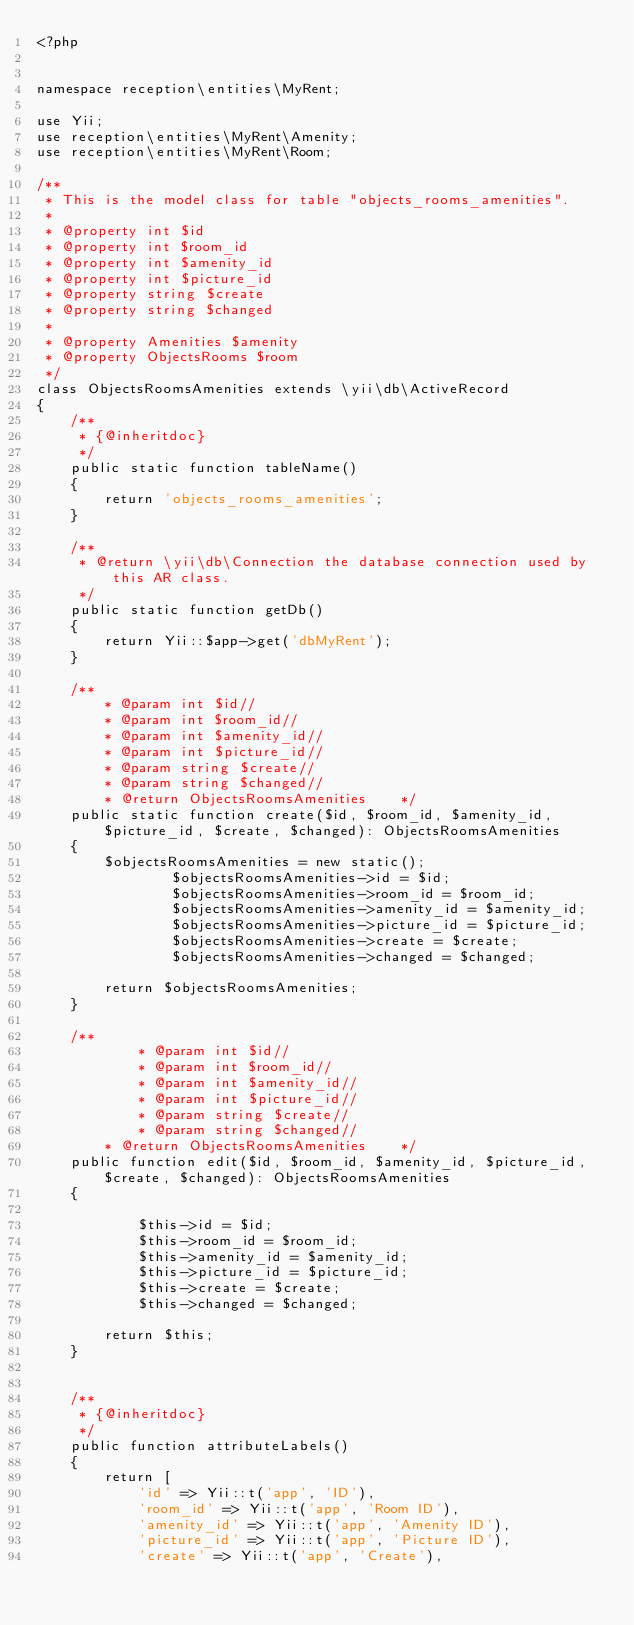Convert code to text. <code><loc_0><loc_0><loc_500><loc_500><_PHP_><?php


namespace reception\entities\MyRent;

use Yii;
use reception\entities\MyRent\Amenity;
use reception\entities\MyRent\Room;

/**
 * This is the model class for table "objects_rooms_amenities".
 *
 * @property int $id
 * @property int $room_id
 * @property int $amenity_id
 * @property int $picture_id
 * @property string $create
 * @property string $changed
 *
 * @property Amenities $amenity
 * @property ObjectsRooms $room
 */
class ObjectsRoomsAmenities extends \yii\db\ActiveRecord
{
    /**
     * {@inheritdoc}
     */
    public static function tableName()
    {
        return 'objects_rooms_amenities';
    }

    /**
     * @return \yii\db\Connection the database connection used by this AR class.
     */
    public static function getDb()
    {
        return Yii::$app->get('dbMyRent');
    }

    /**
        * @param int $id//
        * @param int $room_id//
        * @param int $amenity_id//
        * @param int $picture_id//
        * @param string $create//
        * @param string $changed//
        * @return ObjectsRoomsAmenities    */
    public static function create($id, $room_id, $amenity_id, $picture_id, $create, $changed): ObjectsRoomsAmenities
    {
        $objectsRoomsAmenities = new static();
                $objectsRoomsAmenities->id = $id;
                $objectsRoomsAmenities->room_id = $room_id;
                $objectsRoomsAmenities->amenity_id = $amenity_id;
                $objectsRoomsAmenities->picture_id = $picture_id;
                $objectsRoomsAmenities->create = $create;
                $objectsRoomsAmenities->changed = $changed;
        
        return $objectsRoomsAmenities;
    }

    /**
            * @param int $id//
            * @param int $room_id//
            * @param int $amenity_id//
            * @param int $picture_id//
            * @param string $create//
            * @param string $changed//
        * @return ObjectsRoomsAmenities    */
    public function edit($id, $room_id, $amenity_id, $picture_id, $create, $changed): ObjectsRoomsAmenities
    {

            $this->id = $id;
            $this->room_id = $room_id;
            $this->amenity_id = $amenity_id;
            $this->picture_id = $picture_id;
            $this->create = $create;
            $this->changed = $changed;
    
        return $this;
    }


    /**
     * {@inheritdoc}
     */
    public function attributeLabels()
    {
        return [
            'id' => Yii::t('app', 'ID'),
            'room_id' => Yii::t('app', 'Room ID'),
            'amenity_id' => Yii::t('app', 'Amenity ID'),
            'picture_id' => Yii::t('app', 'Picture ID'),
            'create' => Yii::t('app', 'Create'),</code> 